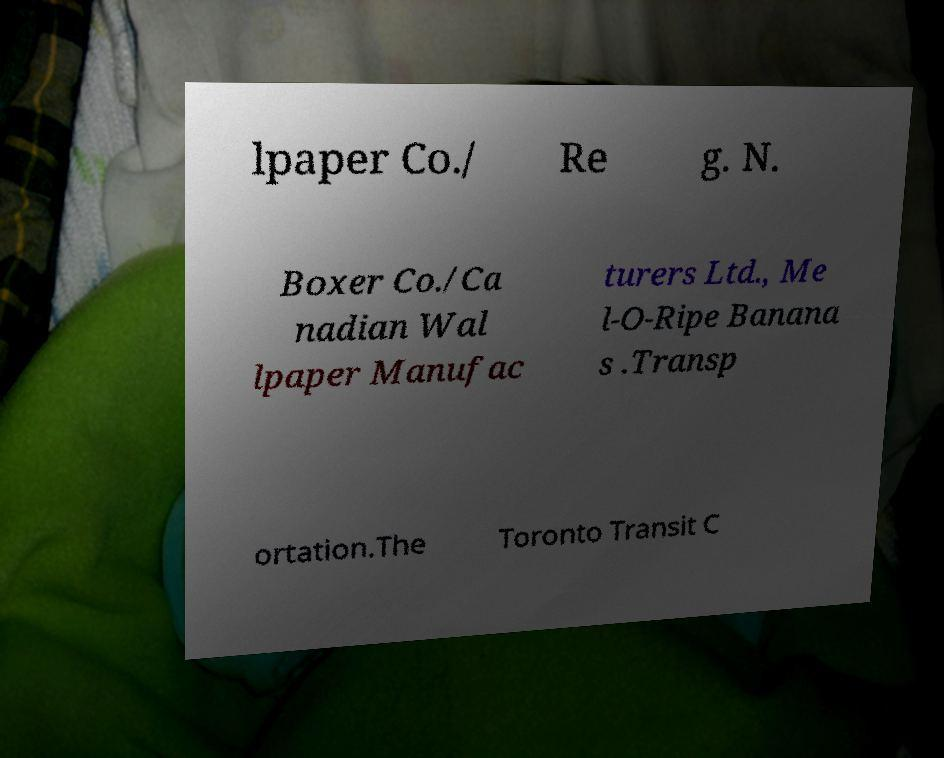Can you read and provide the text displayed in the image?This photo seems to have some interesting text. Can you extract and type it out for me? lpaper Co./ Re g. N. Boxer Co./Ca nadian Wal lpaper Manufac turers Ltd., Me l-O-Ripe Banana s .Transp ortation.The Toronto Transit C 